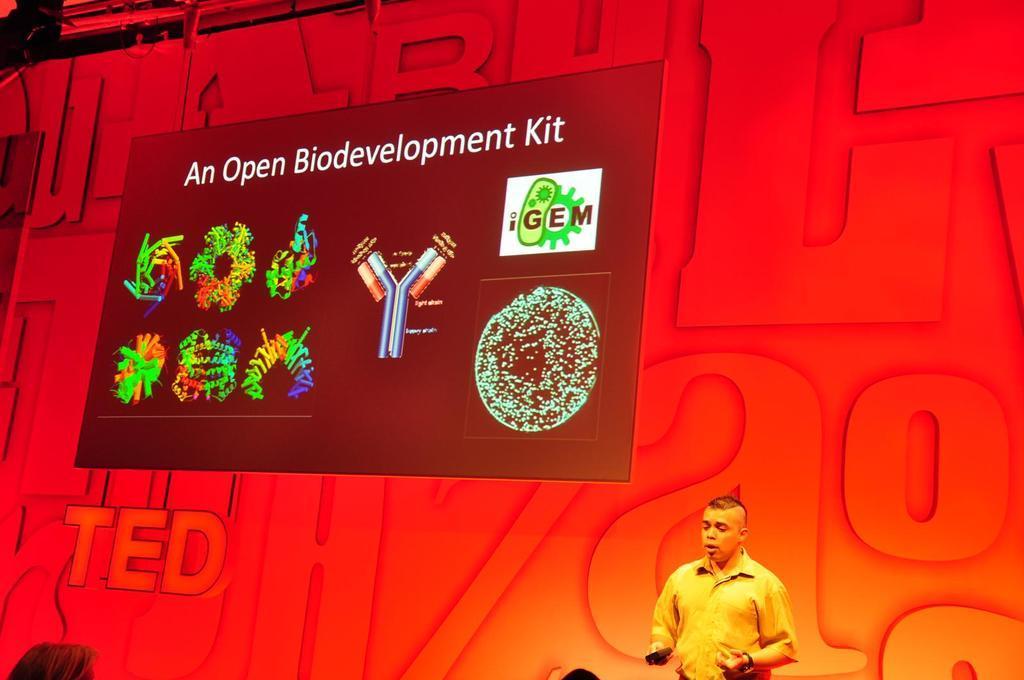Describe this image in one or two sentences. In the image there is a person standing on the right side and behind there is a wall with banner on it, there are images and text on the wall. 